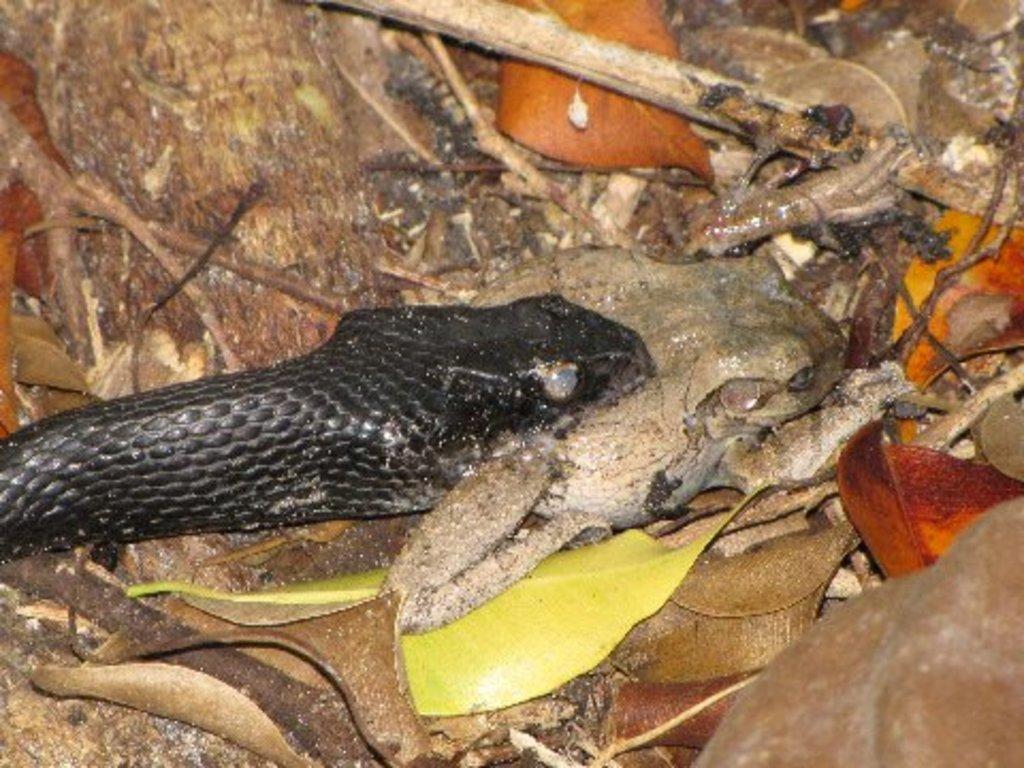Could you give a brief overview of what you see in this image? In this picture we can see a snake, leaves, sticks and some objects on the ground. 